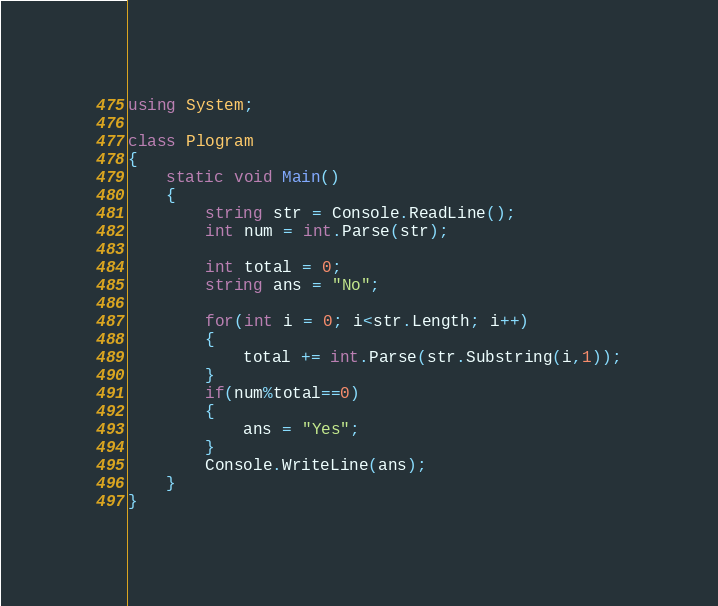Convert code to text. <code><loc_0><loc_0><loc_500><loc_500><_C#_>using System;

class Plogram
{
    static void Main()
    {
        string str = Console.ReadLine();
        int num = int.Parse(str);

        int total = 0;
        string ans = "No";

        for(int i = 0; i<str.Length; i++)
        {
            total += int.Parse(str.Substring(i,1));
        }
        if(num%total==0)
        {
            ans = "Yes";
        }
        Console.WriteLine(ans);
    }
}</code> 